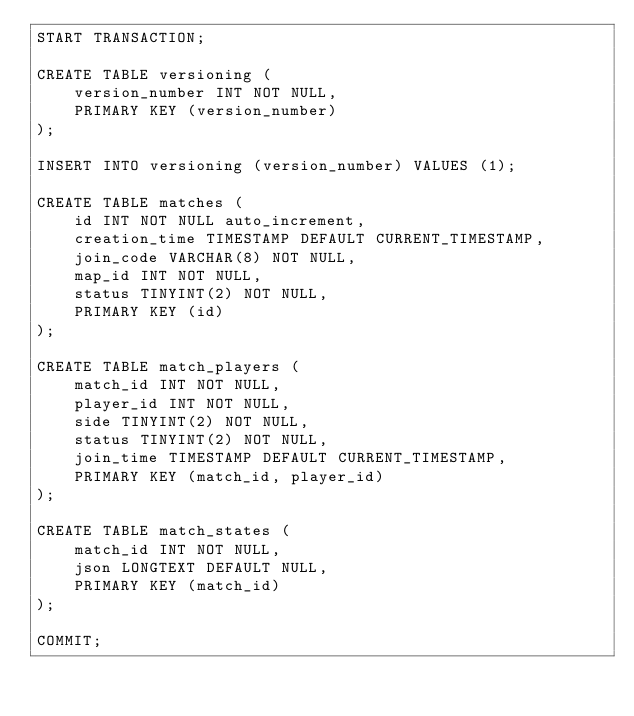Convert code to text. <code><loc_0><loc_0><loc_500><loc_500><_SQL_>START TRANSACTION;

CREATE TABLE versioning (
    version_number INT NOT NULL,
    PRIMARY KEY (version_number)
);

INSERT INTO versioning (version_number) VALUES (1);

CREATE TABLE matches (
    id INT NOT NULL auto_increment,
    creation_time TIMESTAMP DEFAULT CURRENT_TIMESTAMP,
    join_code VARCHAR(8) NOT NULL,
    map_id INT NOT NULL,
    status TINYINT(2) NOT NULL,
    PRIMARY KEY (id)
);

CREATE TABLE match_players (
    match_id INT NOT NULL,
    player_id INT NOT NULL,
    side TINYINT(2) NOT NULL,
    status TINYINT(2) NOT NULL,
    join_time TIMESTAMP DEFAULT CURRENT_TIMESTAMP,
    PRIMARY KEY (match_id, player_id)
);

CREATE TABLE match_states (
    match_id INT NOT NULL,
    json LONGTEXT DEFAULT NULL,
    PRIMARY KEY (match_id)
);

COMMIT;</code> 